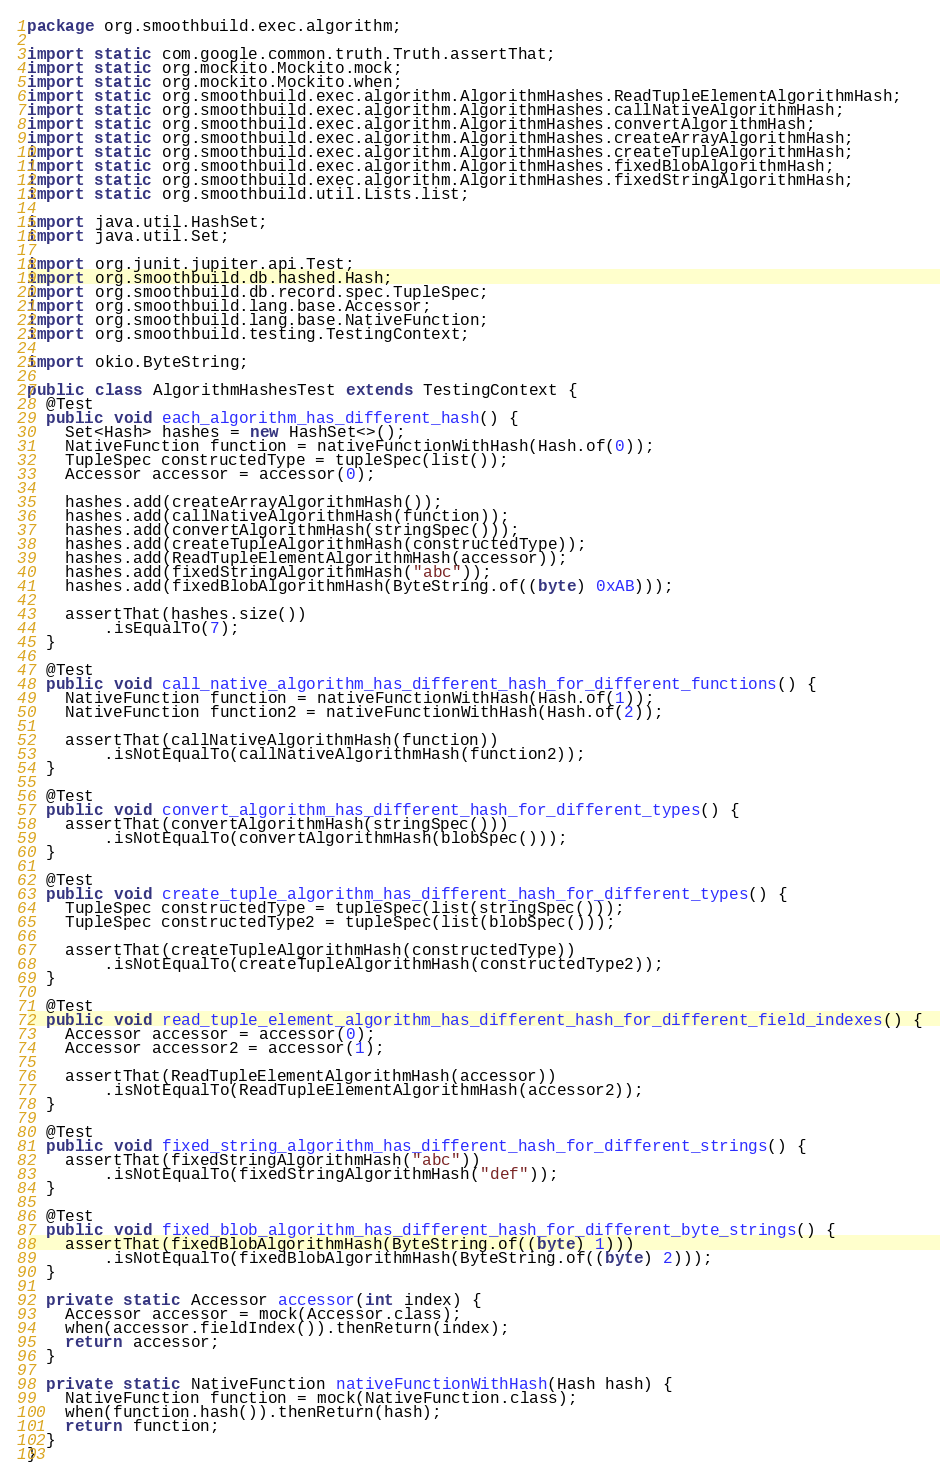<code> <loc_0><loc_0><loc_500><loc_500><_Java_>package org.smoothbuild.exec.algorithm;

import static com.google.common.truth.Truth.assertThat;
import static org.mockito.Mockito.mock;
import static org.mockito.Mockito.when;
import static org.smoothbuild.exec.algorithm.AlgorithmHashes.ReadTupleElementAlgorithmHash;
import static org.smoothbuild.exec.algorithm.AlgorithmHashes.callNativeAlgorithmHash;
import static org.smoothbuild.exec.algorithm.AlgorithmHashes.convertAlgorithmHash;
import static org.smoothbuild.exec.algorithm.AlgorithmHashes.createArrayAlgorithmHash;
import static org.smoothbuild.exec.algorithm.AlgorithmHashes.createTupleAlgorithmHash;
import static org.smoothbuild.exec.algorithm.AlgorithmHashes.fixedBlobAlgorithmHash;
import static org.smoothbuild.exec.algorithm.AlgorithmHashes.fixedStringAlgorithmHash;
import static org.smoothbuild.util.Lists.list;

import java.util.HashSet;
import java.util.Set;

import org.junit.jupiter.api.Test;
import org.smoothbuild.db.hashed.Hash;
import org.smoothbuild.db.record.spec.TupleSpec;
import org.smoothbuild.lang.base.Accessor;
import org.smoothbuild.lang.base.NativeFunction;
import org.smoothbuild.testing.TestingContext;

import okio.ByteString;

public class AlgorithmHashesTest extends TestingContext {
  @Test
  public void each_algorithm_has_different_hash() {
    Set<Hash> hashes = new HashSet<>();
    NativeFunction function = nativeFunctionWithHash(Hash.of(0));
    TupleSpec constructedType = tupleSpec(list());
    Accessor accessor = accessor(0);

    hashes.add(createArrayAlgorithmHash());
    hashes.add(callNativeAlgorithmHash(function));
    hashes.add(convertAlgorithmHash(stringSpec()));
    hashes.add(createTupleAlgorithmHash(constructedType));
    hashes.add(ReadTupleElementAlgorithmHash(accessor));
    hashes.add(fixedStringAlgorithmHash("abc"));
    hashes.add(fixedBlobAlgorithmHash(ByteString.of((byte) 0xAB)));

    assertThat(hashes.size())
        .isEqualTo(7);
  }

  @Test
  public void call_native_algorithm_has_different_hash_for_different_functions() {
    NativeFunction function = nativeFunctionWithHash(Hash.of(1));
    NativeFunction function2 = nativeFunctionWithHash(Hash.of(2));

    assertThat(callNativeAlgorithmHash(function))
        .isNotEqualTo(callNativeAlgorithmHash(function2));
  }

  @Test
  public void convert_algorithm_has_different_hash_for_different_types() {
    assertThat(convertAlgorithmHash(stringSpec()))
        .isNotEqualTo(convertAlgorithmHash(blobSpec()));
  }

  @Test
  public void create_tuple_algorithm_has_different_hash_for_different_types() {
    TupleSpec constructedType = tupleSpec(list(stringSpec()));
    TupleSpec constructedType2 = tupleSpec(list(blobSpec()));

    assertThat(createTupleAlgorithmHash(constructedType))
        .isNotEqualTo(createTupleAlgorithmHash(constructedType2));
  }

  @Test
  public void read_tuple_element_algorithm_has_different_hash_for_different_field_indexes() {
    Accessor accessor = accessor(0);
    Accessor accessor2 = accessor(1);

    assertThat(ReadTupleElementAlgorithmHash(accessor))
        .isNotEqualTo(ReadTupleElementAlgorithmHash(accessor2));
  }

  @Test
  public void fixed_string_algorithm_has_different_hash_for_different_strings() {
    assertThat(fixedStringAlgorithmHash("abc"))
        .isNotEqualTo(fixedStringAlgorithmHash("def"));
  }

  @Test
  public void fixed_blob_algorithm_has_different_hash_for_different_byte_strings() {
    assertThat(fixedBlobAlgorithmHash(ByteString.of((byte) 1)))
        .isNotEqualTo(fixedBlobAlgorithmHash(ByteString.of((byte) 2)));
  }

  private static Accessor accessor(int index) {
    Accessor accessor = mock(Accessor.class);
    when(accessor.fieldIndex()).thenReturn(index);
    return accessor;
  }

  private static NativeFunction nativeFunctionWithHash(Hash hash) {
    NativeFunction function = mock(NativeFunction.class);
    when(function.hash()).thenReturn(hash);
    return function;
  }
}
</code> 